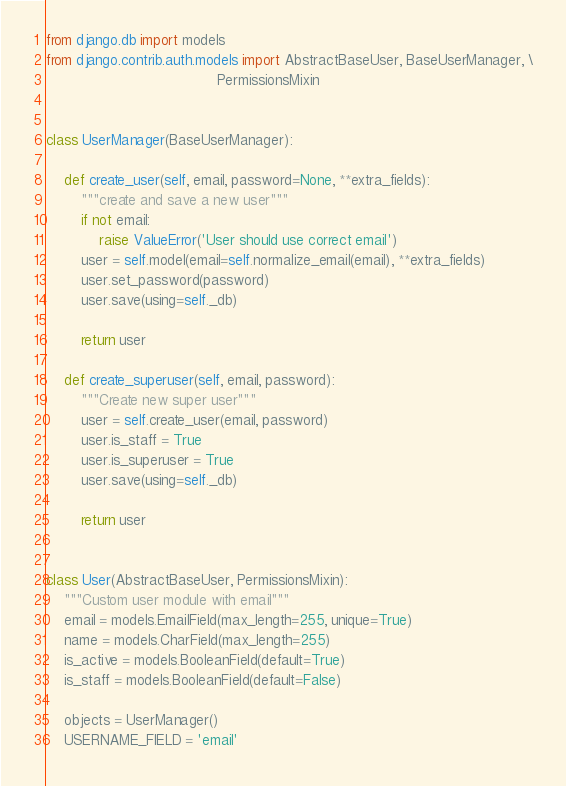<code> <loc_0><loc_0><loc_500><loc_500><_Python_>from django.db import models
from django.contrib.auth.models import AbstractBaseUser, BaseUserManager, \
                                       PermissionsMixin


class UserManager(BaseUserManager):

    def create_user(self, email, password=None, **extra_fields):
        """create and save a new user"""
        if not email:
            raise ValueError('User should use correct email')
        user = self.model(email=self.normalize_email(email), **extra_fields)
        user.set_password(password)
        user.save(using=self._db)

        return user

    def create_superuser(self, email, password):
        """Create new super user"""
        user = self.create_user(email, password)
        user.is_staff = True
        user.is_superuser = True
        user.save(using=self._db)

        return user


class User(AbstractBaseUser, PermissionsMixin):
    """Custom user module with email"""
    email = models.EmailField(max_length=255, unique=True)
    name = models.CharField(max_length=255)
    is_active = models.BooleanField(default=True)
    is_staff = models.BooleanField(default=False)

    objects = UserManager()
    USERNAME_FIELD = 'email'
</code> 